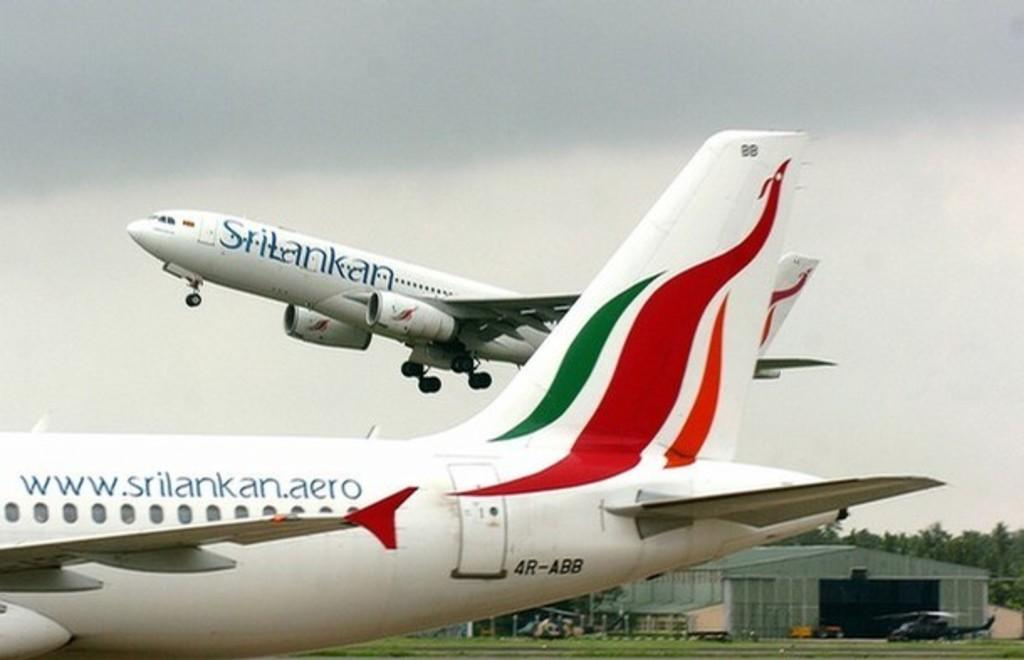<image>
Render a clear and concise summary of the photo. Two planes, one in the air and one on the ground both from Srilankan airlines. 